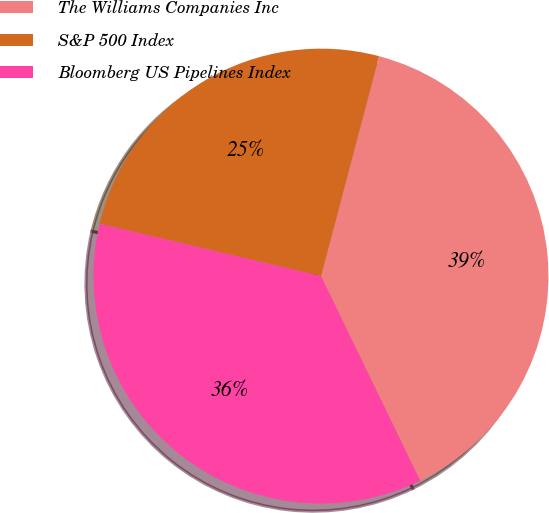Convert chart to OTSL. <chart><loc_0><loc_0><loc_500><loc_500><pie_chart><fcel>The Williams Companies Inc<fcel>S&P 500 Index<fcel>Bloomberg US Pipelines Index<nl><fcel>38.71%<fcel>25.41%<fcel>35.89%<nl></chart> 